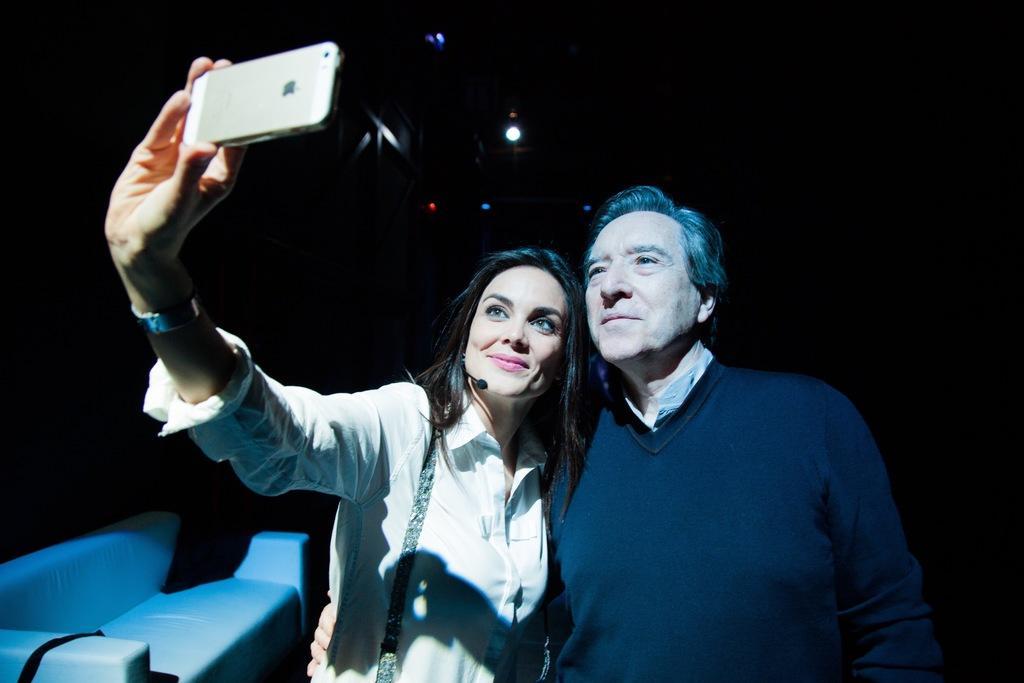Describe this image in one or two sentences. In this image I can see two people with different color dresses. I can see one person holding the mobile. To the left I can see the couch. I can see the light and there is a black background. 